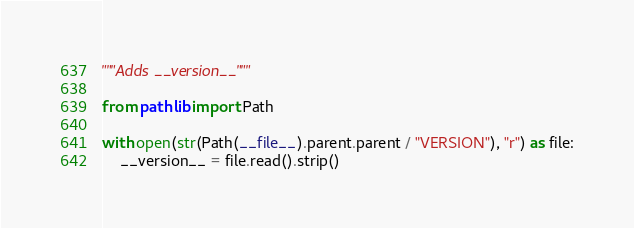<code> <loc_0><loc_0><loc_500><loc_500><_Python_>"""Adds __version__"""

from pathlib import Path

with open(str(Path(__file__).parent.parent / "VERSION"), "r") as file:
    __version__ = file.read().strip()
</code> 